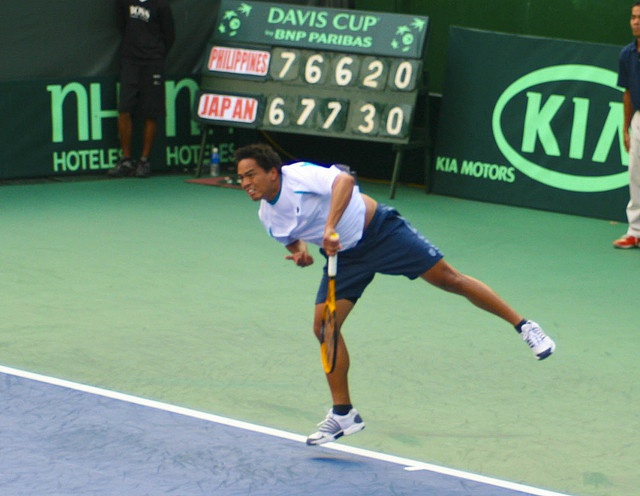Describe the objects in this image and their specific colors. I can see people in black, lavender, darkgray, and navy tones, people in black, maroon, gray, and darkgray tones, people in black, darkgray, lightgray, and maroon tones, tennis racket in black, olive, maroon, and orange tones, and bottle in black, gray, blue, and darkblue tones in this image. 